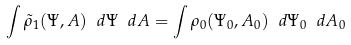<formula> <loc_0><loc_0><loc_500><loc_500>\int \tilde { \rho } _ { 1 } ( \Psi , A ) \ d \Psi \ d A = \int \rho _ { 0 } ( \Psi _ { 0 } , A _ { 0 } ) \ d \Psi _ { 0 } \ d A _ { 0 }</formula> 